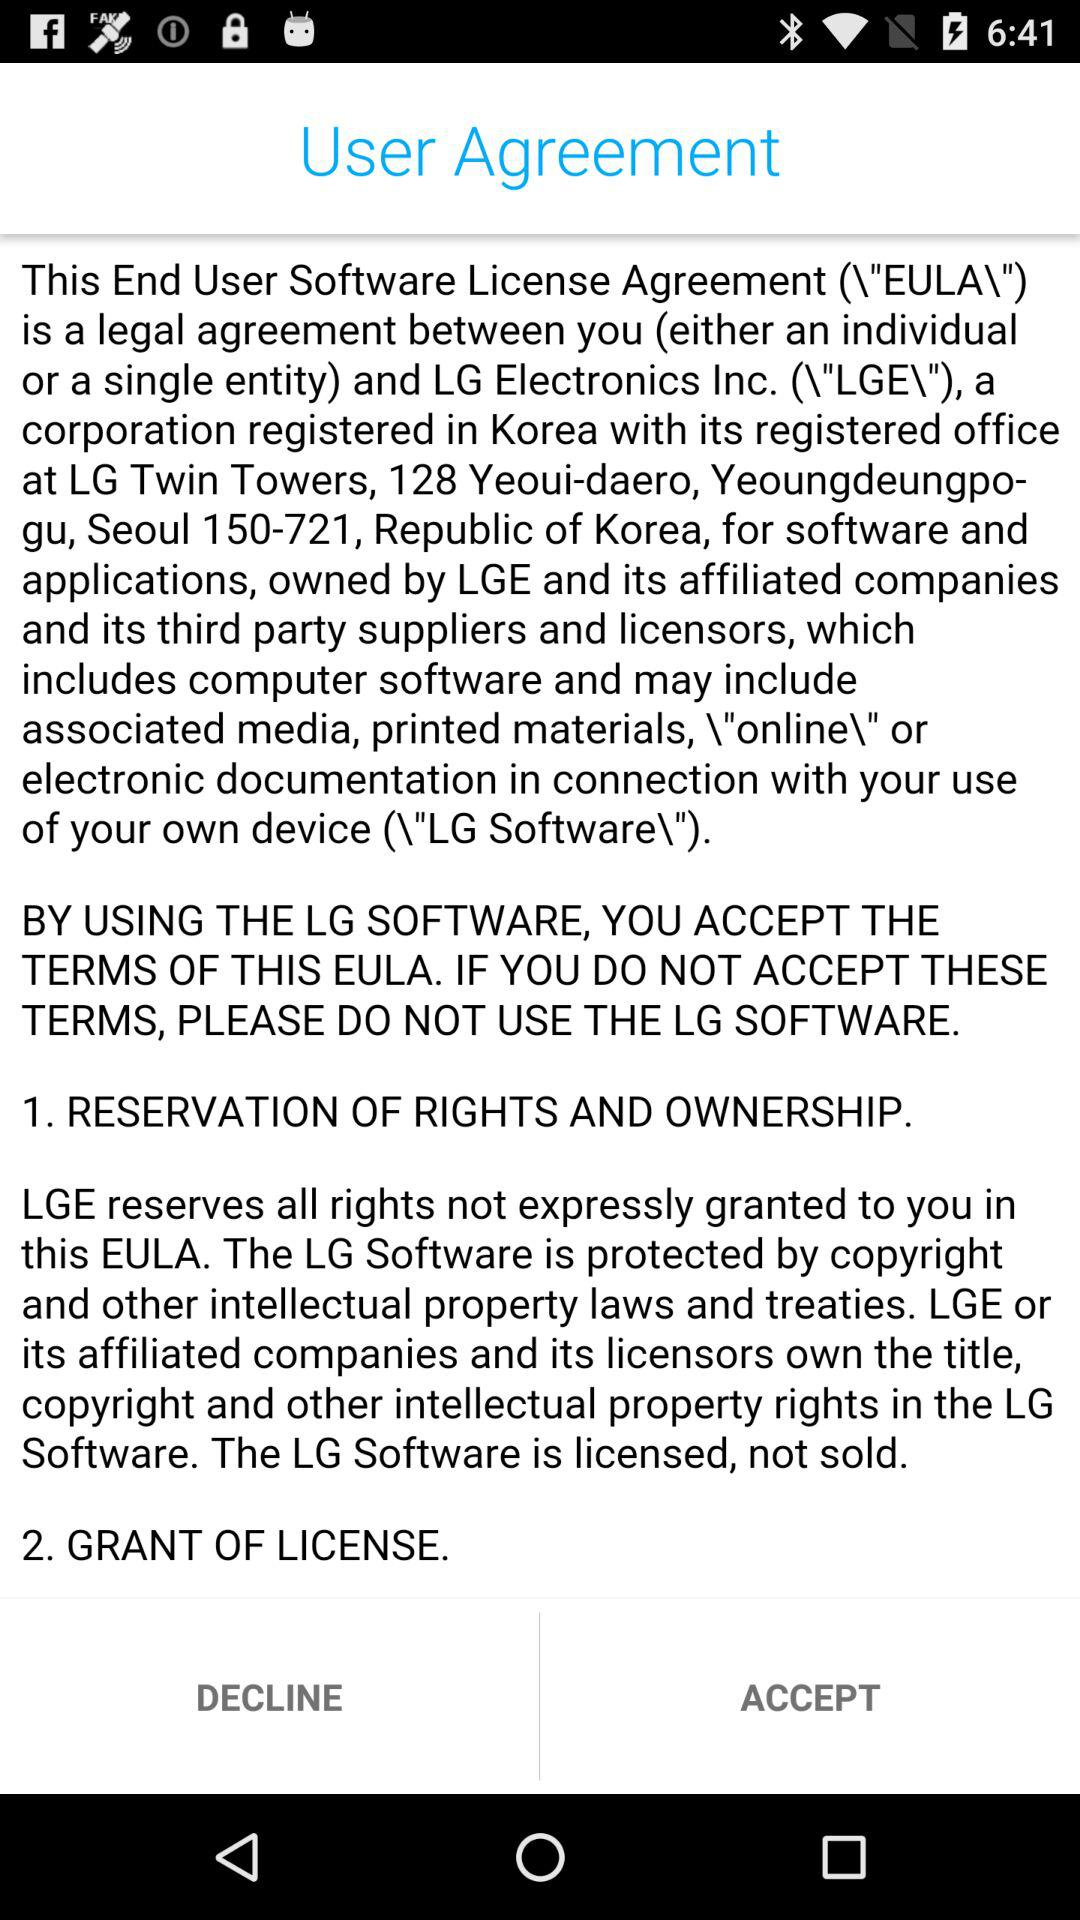What is the full form of EULA? The full form of EULA is End User Software License Agreement. 